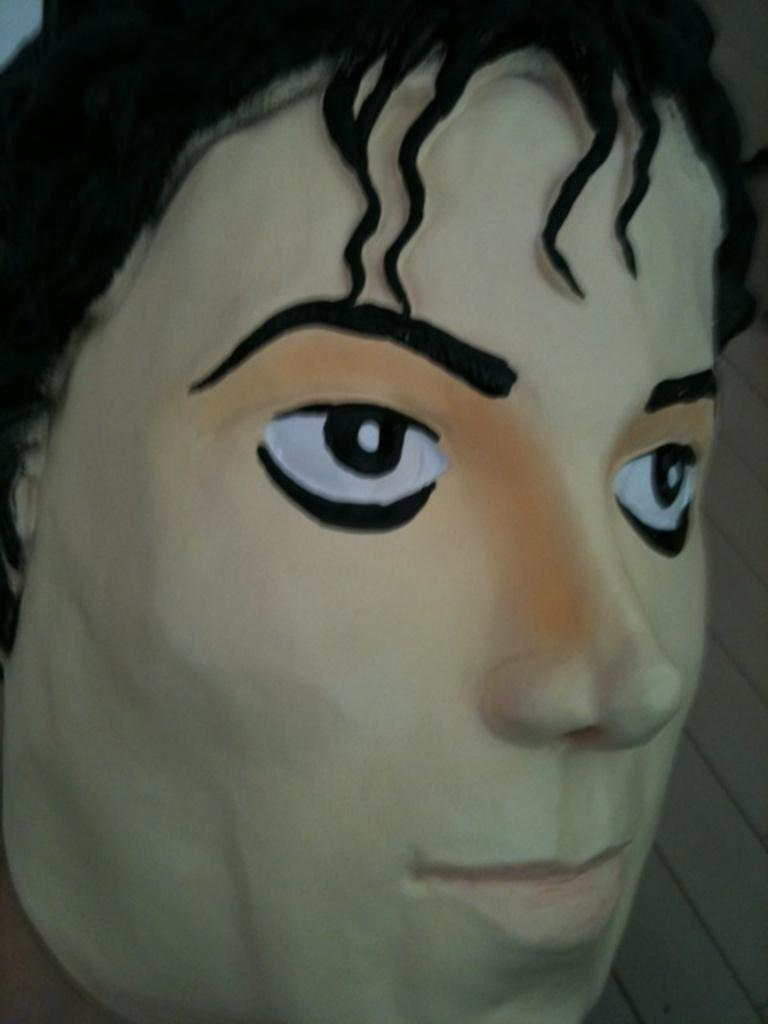What is the main subject of the image? The main subject of the image is a human face. What type of beginner's tool is being used by the human face in the image? There is no tool or activity depicted in the image; it is a static depiction of a human face. 